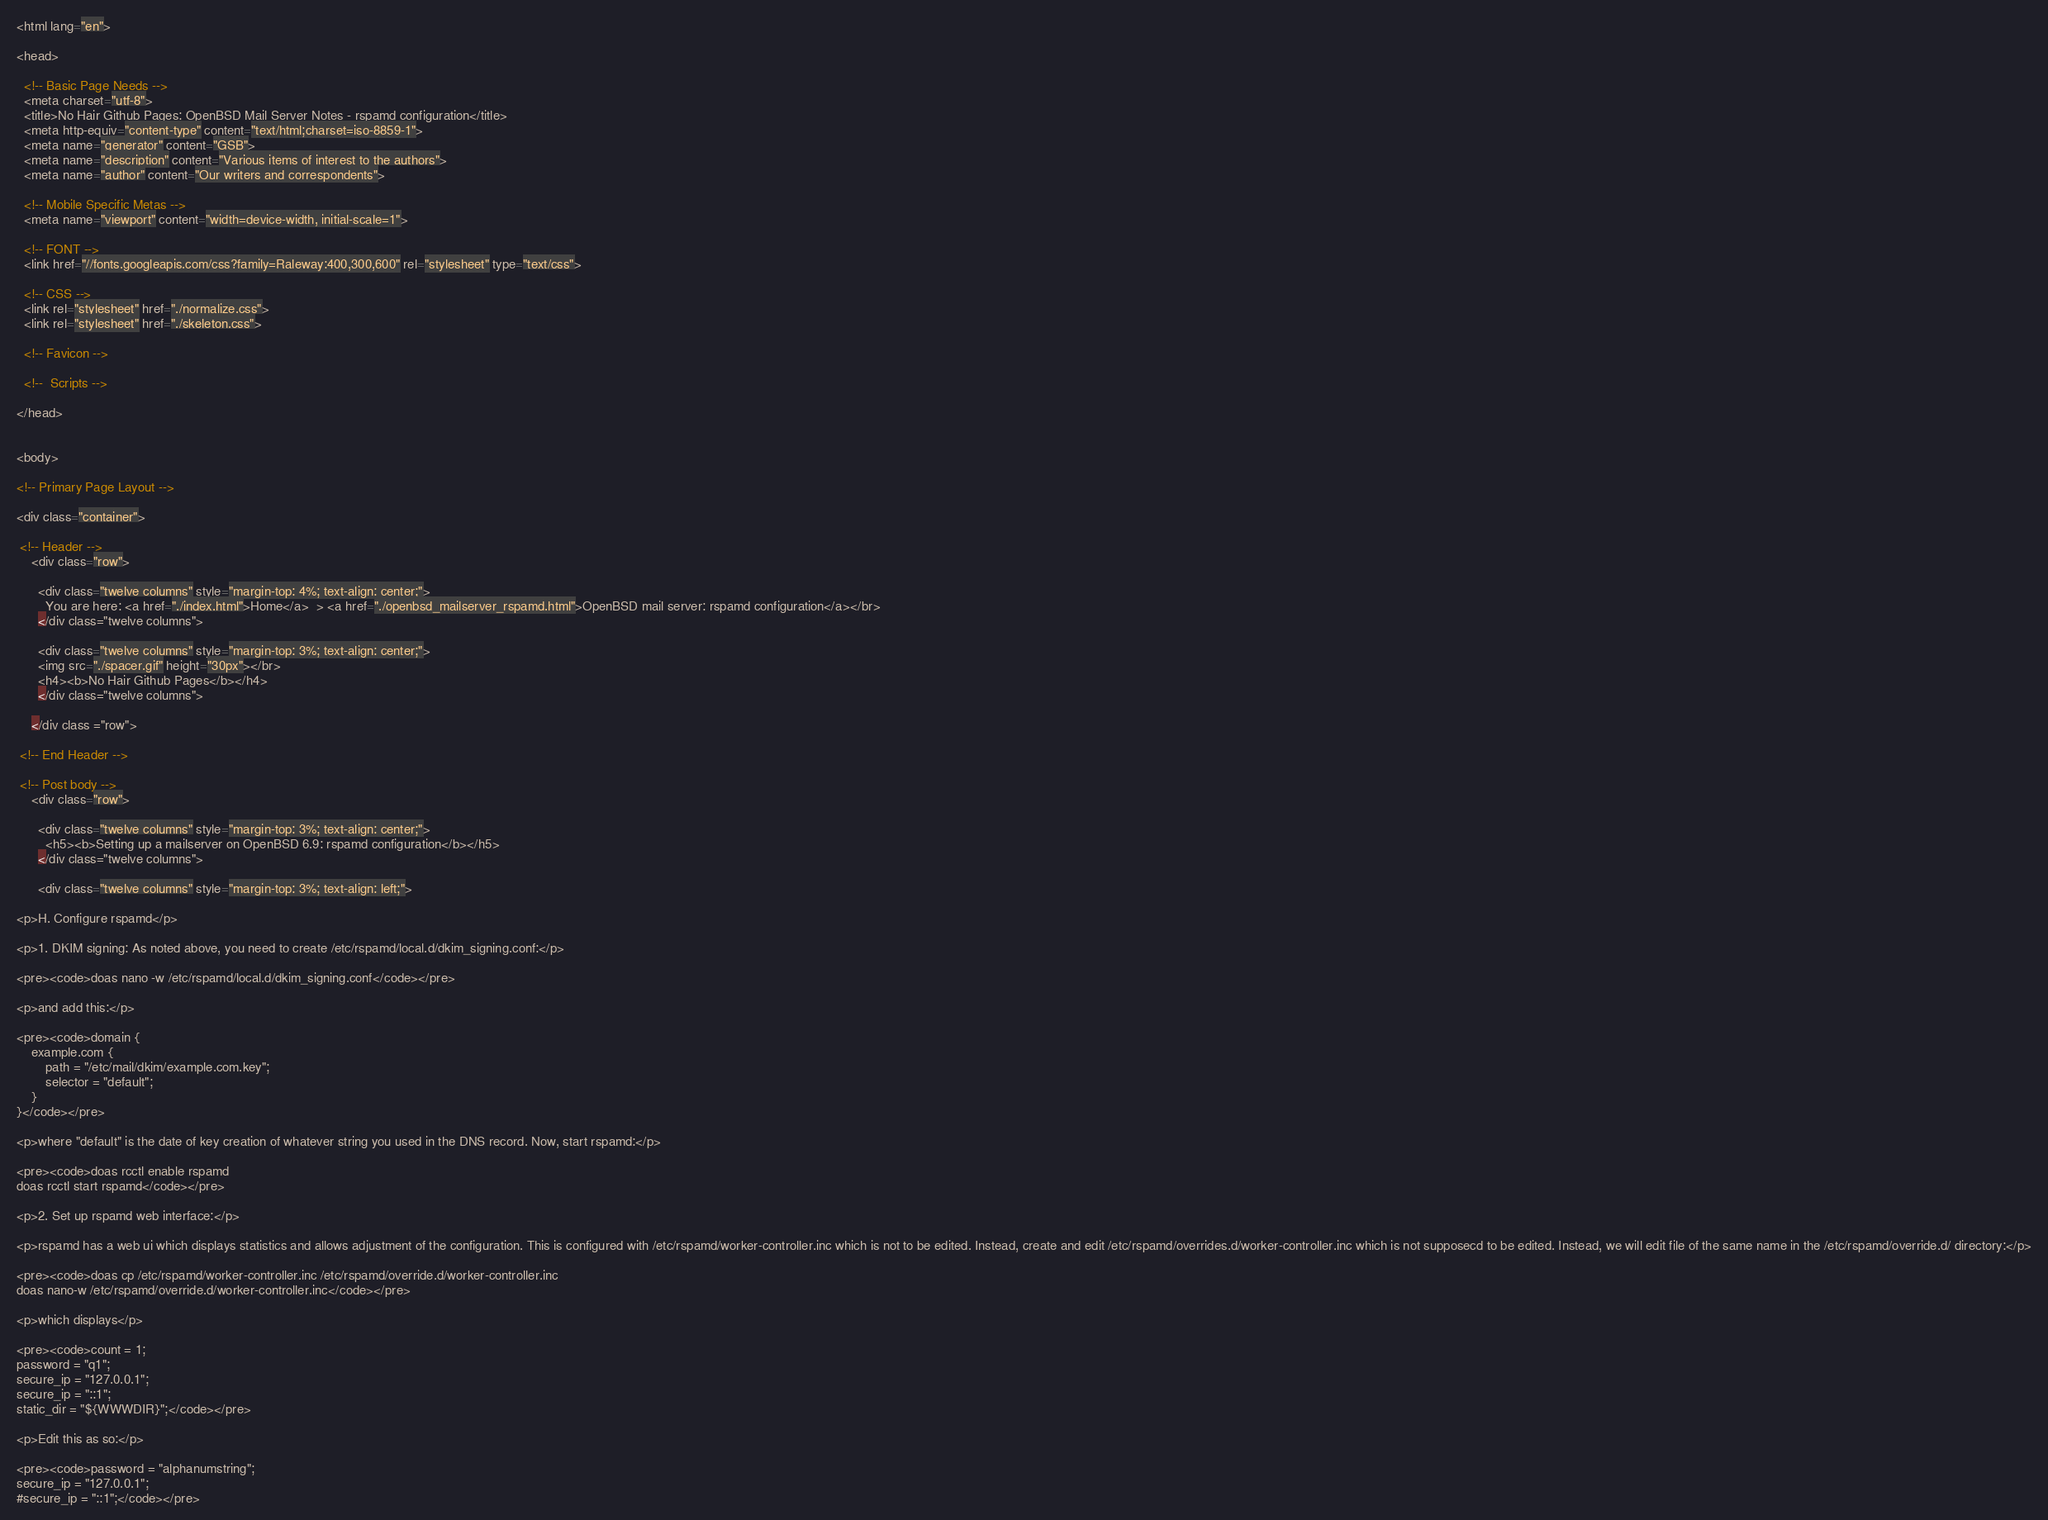<code> <loc_0><loc_0><loc_500><loc_500><_HTML_><html lang="en">

<head>

  <!-- Basic Page Needs -->
  <meta charset="utf-8">
  <title>No Hair Github Pages: OpenBSD Mail Server Notes - rspamd configuration</title>
  <meta http-equiv="content-type" content="text/html;charset=iso-8859-1">
  <meta name="generator" content="GSB">
  <meta name="description" content="Various items of interest to the authors">
  <meta name="author" content="Our writers and correspondents">

  <!-- Mobile Specific Metas -->
  <meta name="viewport" content="width=device-width, initial-scale=1">

  <!-- FONT -->
  <link href="//fonts.googleapis.com/css?family=Raleway:400,300,600" rel="stylesheet" type="text/css">

  <!-- CSS -->
  <link rel="stylesheet" href="./normalize.css">
  <link rel="stylesheet" href="./skeleton.css">

  <!-- Favicon -->

  <!--  Scripts -->
  
</head>


<body>

<!-- Primary Page Layout -->
  
<div class="container">
  
 <!-- Header -->
    <div class="row">
		
      <div class="twelve columns" style="margin-top: 4%; text-align: center;">
        You are here: <a href="./index.html">Home</a>  > <a href="./openbsd_mailserver_rspamd.html">OpenBSD mail server: rspamd configuration</a></br>
      </div class="twelve columns">
      
      <div class="twelve columns" style="margin-top: 3%; text-align: center;">
	  <img src="./spacer.gif" height="30px"></br>
	  <h4><b>No Hair Github Pages</b></h4>
	  </div class="twelve columns">

 	</div class ="row">

 <!-- End Header -->

 <!-- Post body -->
	<div class="row">
	
	  <div class="twelve columns" style="margin-top: 3%; text-align: center;">
		<h5><b>Setting up a mailserver on OpenBSD 6.9: rspamd configuration</b></h5>
	  </div class="twelve columns">

	  <div class="twelve columns" style="margin-top: 3%; text-align: left;">
		
<p>H. Configure rspamd</p>

<p>1. DKIM signing: As noted above, you need to create /etc/rspamd/local.d/dkim_signing.conf:</p>

<pre><code>doas nano -w /etc/rspamd/local.d/dkim_signing.conf</code></pre>

<p>and add this:</p>

<pre><code>domain {
    example.com {
        path = "/etc/mail/dkim/example.com.key";
        selector = "default";
    }
}</code></pre>

<p>where "default" is the date of key creation of whatever string you used in the DNS record. Now, start rspamd:</p>

<pre><code>doas rcctl enable rspamd
doas rcctl start rspamd</code></pre>

<p>2. Set up rspamd web interface:</p>

<p>rspamd has a web ui which displays statistics and allows adjustment of the configuration. This is configured with /etc/rspamd/worker-controller.inc which is not to be edited. Instead, create and edit /etc/rspamd/overrides.d/worker-controller.inc which is not supposecd to be edited. Instead, we will edit file of the same name in the /etc/rspamd/override.d/ directory:</p>

<pre><code>doas cp /etc/rspamd/worker-controller.inc /etc/rspamd/override.d/worker-controller.inc
doas nano-w /etc/rspamd/override.d/worker-controller.inc</code></pre>

<p>which displays</p>

<pre><code>count = 1;
password = "q1";
secure_ip = "127.0.0.1";
secure_ip = "::1";
static_dir = "${WWWDIR}";</code></pre>

<p>Edit this as so:</p>

<pre><code>password = "alphanumstring";
secure_ip = "127.0.0.1";
#secure_ip = "::1";</code></pre>
</code> 